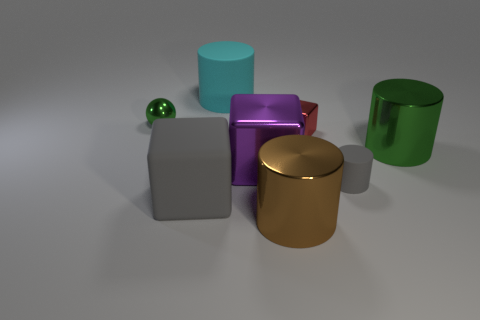What is the shape of the object that is the same color as the shiny ball?
Offer a very short reply. Cylinder. How big is the cyan cylinder that is behind the large rubber thing that is in front of the tiny green ball?
Keep it short and to the point. Large. What number of green objects are big rubber cubes or big spheres?
Provide a succinct answer. 0. Are there fewer gray rubber things in front of the small green metal object than red objects in front of the green cylinder?
Offer a very short reply. No. Do the ball and the gray object that is to the left of the red cube have the same size?
Your answer should be very brief. No. What number of green shiny objects are the same size as the matte block?
Make the answer very short. 1. How many small things are cyan things or purple shiny cubes?
Make the answer very short. 0. Is there a big brown rubber ball?
Your answer should be compact. No. Is the number of shiny cylinders behind the purple thing greater than the number of rubber things that are in front of the big gray rubber cube?
Provide a succinct answer. Yes. There is a rubber cylinder on the right side of the cylinder on the left side of the purple cube; what color is it?
Make the answer very short. Gray. 